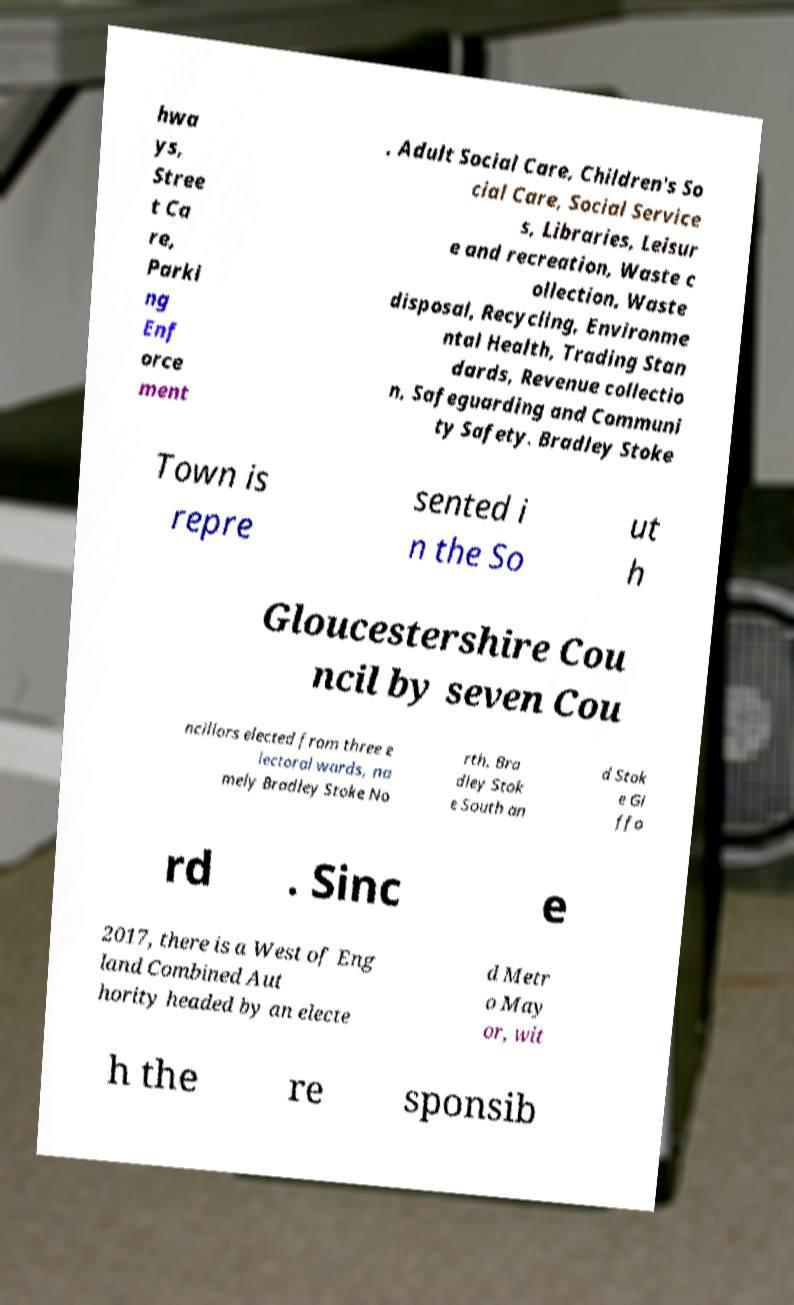Could you assist in decoding the text presented in this image and type it out clearly? hwa ys, Stree t Ca re, Parki ng Enf orce ment , Adult Social Care, Children's So cial Care, Social Service s, Libraries, Leisur e and recreation, Waste c ollection, Waste disposal, Recycling, Environme ntal Health, Trading Stan dards, Revenue collectio n, Safeguarding and Communi ty Safety. Bradley Stoke Town is repre sented i n the So ut h Gloucestershire Cou ncil by seven Cou ncillors elected from three e lectoral wards, na mely Bradley Stoke No rth, Bra dley Stok e South an d Stok e Gi ffo rd . Sinc e 2017, there is a West of Eng land Combined Aut hority headed by an electe d Metr o May or, wit h the re sponsib 